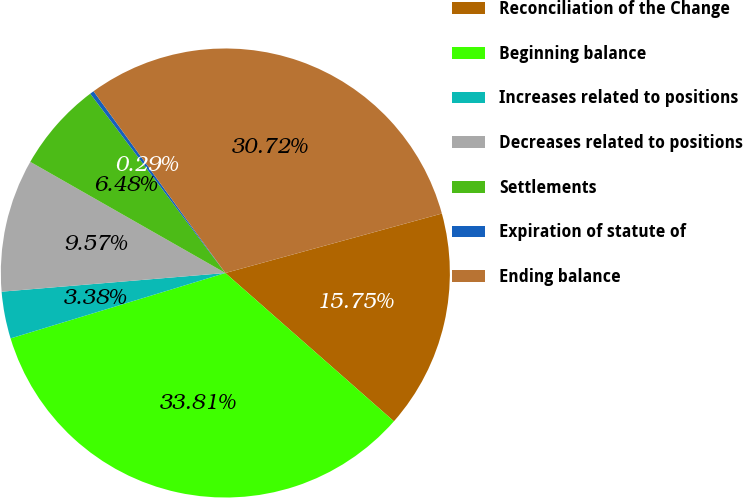Convert chart. <chart><loc_0><loc_0><loc_500><loc_500><pie_chart><fcel>Reconciliation of the Change<fcel>Beginning balance<fcel>Increases related to positions<fcel>Decreases related to positions<fcel>Settlements<fcel>Expiration of statute of<fcel>Ending balance<nl><fcel>15.75%<fcel>33.81%<fcel>3.38%<fcel>9.57%<fcel>6.48%<fcel>0.29%<fcel>30.72%<nl></chart> 